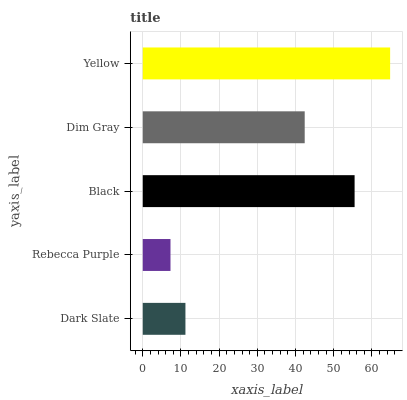Is Rebecca Purple the minimum?
Answer yes or no. Yes. Is Yellow the maximum?
Answer yes or no. Yes. Is Black the minimum?
Answer yes or no. No. Is Black the maximum?
Answer yes or no. No. Is Black greater than Rebecca Purple?
Answer yes or no. Yes. Is Rebecca Purple less than Black?
Answer yes or no. Yes. Is Rebecca Purple greater than Black?
Answer yes or no. No. Is Black less than Rebecca Purple?
Answer yes or no. No. Is Dim Gray the high median?
Answer yes or no. Yes. Is Dim Gray the low median?
Answer yes or no. Yes. Is Rebecca Purple the high median?
Answer yes or no. No. Is Yellow the low median?
Answer yes or no. No. 